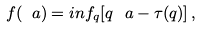Convert formula to latex. <formula><loc_0><loc_0><loc_500><loc_500>f ( \ a ) = i n f _ { q } [ q \, \ a - \tau ( q ) ] \, ,</formula> 